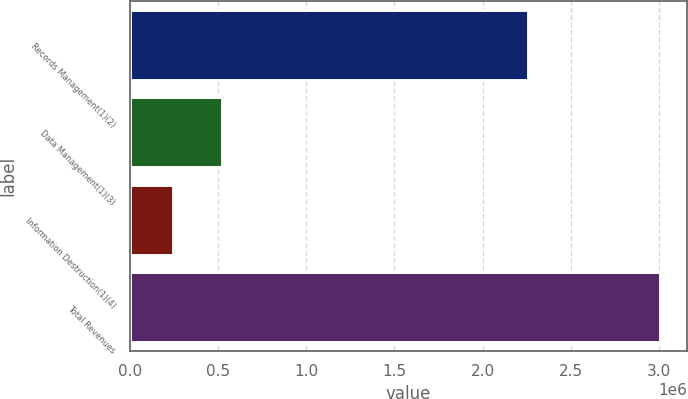<chart> <loc_0><loc_0><loc_500><loc_500><bar_chart><fcel>Records Management(1)(2)<fcel>Data Management(1)(3)<fcel>Information Destruction(1)(4)<fcel>Total Revenues<nl><fcel>2.25521e+06<fcel>519956<fcel>243509<fcel>3.00798e+06<nl></chart> 